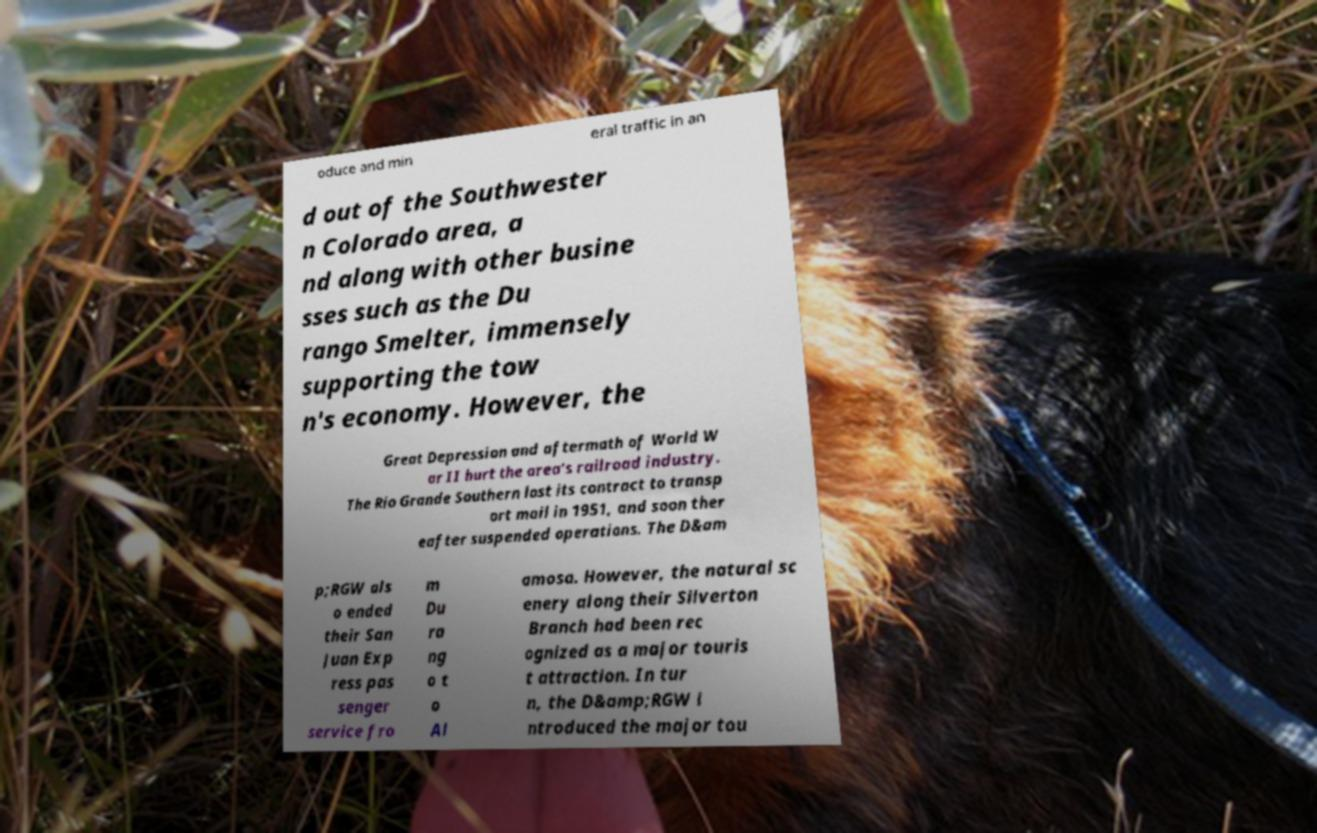What messages or text are displayed in this image? I need them in a readable, typed format. oduce and min eral traffic in an d out of the Southwester n Colorado area, a nd along with other busine sses such as the Du rango Smelter, immensely supporting the tow n's economy. However, the Great Depression and aftermath of World W ar II hurt the area's railroad industry. The Rio Grande Southern lost its contract to transp ort mail in 1951, and soon ther eafter suspended operations. The D&am p;RGW als o ended their San Juan Exp ress pas senger service fro m Du ra ng o t o Al amosa. However, the natural sc enery along their Silverton Branch had been rec ognized as a major touris t attraction. In tur n, the D&amp;RGW i ntroduced the major tou 